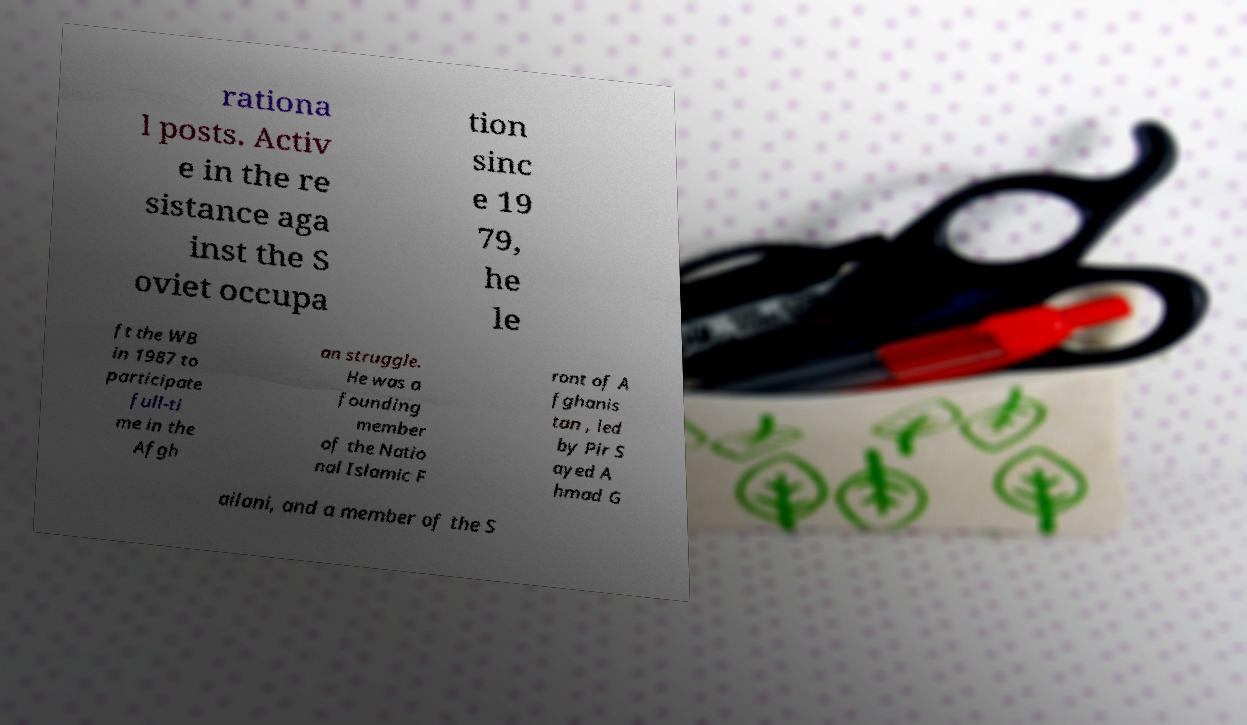Could you assist in decoding the text presented in this image and type it out clearly? rationa l posts. Activ e in the re sistance aga inst the S oviet occupa tion sinc e 19 79, he le ft the WB in 1987 to participate full-ti me in the Afgh an struggle. He was a founding member of the Natio nal Islamic F ront of A fghanis tan , led by Pir S ayed A hmad G ailani, and a member of the S 